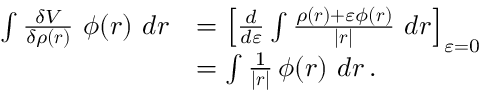Convert formula to latex. <formula><loc_0><loc_0><loc_500><loc_500>{ \begin{array} { r l } { \int { \frac { \delta V } { \delta \rho ( { r } ) } } \ \phi ( { r } ) \ d { r } } & { = \left [ { \frac { d } { d \varepsilon } } \int { \frac { \rho ( { r } ) + \varepsilon \phi ( { r } ) } { | { r } | } } \ d { r } \right ] _ { \varepsilon = 0 } } \\ & { = \int { \frac { 1 } { | { r } | } } \, \phi ( { r } ) \ d { r } \, . } \end{array} }</formula> 